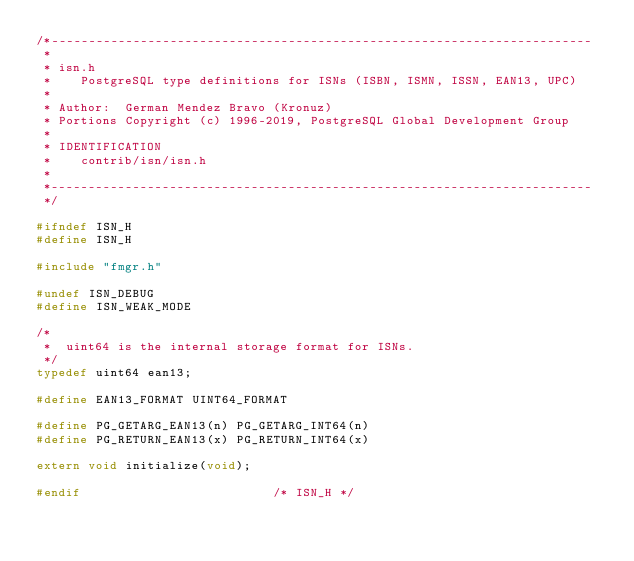<code> <loc_0><loc_0><loc_500><loc_500><_C_>/*-------------------------------------------------------------------------
 *
 * isn.h
 *	  PostgreSQL type definitions for ISNs (ISBN, ISMN, ISSN, EAN13, UPC)
 *
 * Author:	German Mendez Bravo (Kronuz)
 * Portions Copyright (c) 1996-2019, PostgreSQL Global Development Group
 *
 * IDENTIFICATION
 *	  contrib/isn/isn.h
 *
 *-------------------------------------------------------------------------
 */

#ifndef ISN_H
#define ISN_H

#include "fmgr.h"

#undef ISN_DEBUG
#define ISN_WEAK_MODE

/*
 *	uint64 is the internal storage format for ISNs.
 */
typedef uint64 ean13;

#define EAN13_FORMAT UINT64_FORMAT

#define PG_GETARG_EAN13(n) PG_GETARG_INT64(n)
#define PG_RETURN_EAN13(x) PG_RETURN_INT64(x)

extern void initialize(void);

#endif							/* ISN_H */
</code> 